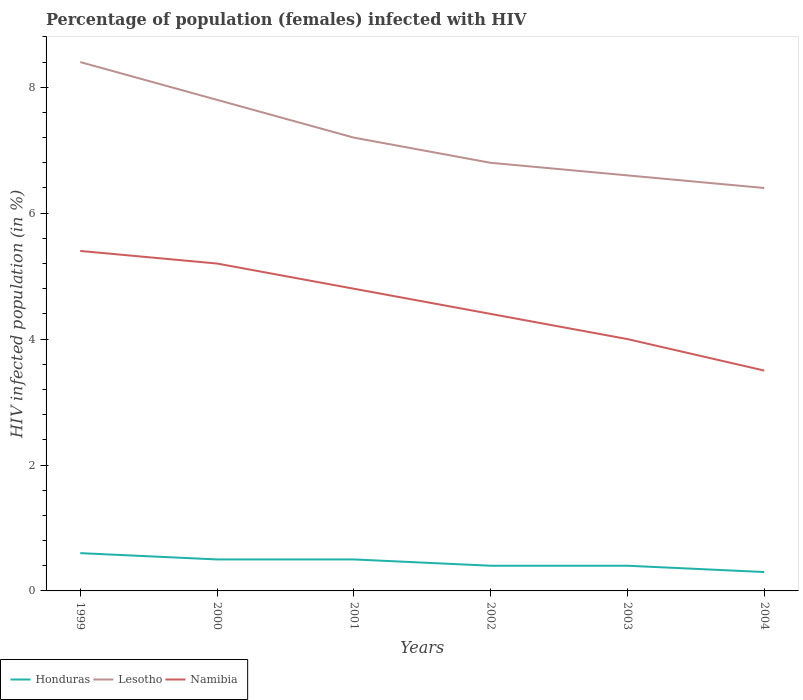How many different coloured lines are there?
Provide a short and direct response. 3. Across all years, what is the maximum percentage of HIV infected female population in Namibia?
Ensure brevity in your answer.  3.5. What is the total percentage of HIV infected female population in Honduras in the graph?
Offer a very short reply. 0.2. What is the difference between the highest and the lowest percentage of HIV infected female population in Lesotho?
Provide a succinct answer. 3. How many lines are there?
Your answer should be compact. 3. Are the values on the major ticks of Y-axis written in scientific E-notation?
Make the answer very short. No. Does the graph contain any zero values?
Provide a succinct answer. No. How are the legend labels stacked?
Your response must be concise. Horizontal. What is the title of the graph?
Your answer should be very brief. Percentage of population (females) infected with HIV. Does "Somalia" appear as one of the legend labels in the graph?
Offer a terse response. No. What is the label or title of the X-axis?
Your answer should be very brief. Years. What is the label or title of the Y-axis?
Offer a terse response. HIV infected population (in %). What is the HIV infected population (in %) in Namibia in 1999?
Your answer should be compact. 5.4. What is the HIV infected population (in %) of Honduras in 2000?
Ensure brevity in your answer.  0.5. What is the HIV infected population (in %) of Namibia in 2000?
Give a very brief answer. 5.2. What is the HIV infected population (in %) of Honduras in 2001?
Provide a succinct answer. 0.5. What is the HIV infected population (in %) of Namibia in 2001?
Your answer should be compact. 4.8. What is the HIV infected population (in %) in Lesotho in 2002?
Keep it short and to the point. 6.8. What is the HIV infected population (in %) in Namibia in 2002?
Ensure brevity in your answer.  4.4. What is the HIV infected population (in %) of Namibia in 2003?
Give a very brief answer. 4. What is the HIV infected population (in %) of Honduras in 2004?
Your answer should be very brief. 0.3. What is the HIV infected population (in %) of Lesotho in 2004?
Keep it short and to the point. 6.4. Across all years, what is the maximum HIV infected population (in %) in Honduras?
Offer a terse response. 0.6. Across all years, what is the maximum HIV infected population (in %) in Lesotho?
Offer a very short reply. 8.4. Across all years, what is the minimum HIV infected population (in %) in Honduras?
Your answer should be very brief. 0.3. Across all years, what is the minimum HIV infected population (in %) of Lesotho?
Your answer should be very brief. 6.4. Across all years, what is the minimum HIV infected population (in %) in Namibia?
Your answer should be very brief. 3.5. What is the total HIV infected population (in %) of Honduras in the graph?
Give a very brief answer. 2.7. What is the total HIV infected population (in %) of Lesotho in the graph?
Offer a terse response. 43.2. What is the total HIV infected population (in %) in Namibia in the graph?
Offer a very short reply. 27.3. What is the difference between the HIV infected population (in %) in Lesotho in 1999 and that in 2000?
Offer a very short reply. 0.6. What is the difference between the HIV infected population (in %) of Namibia in 1999 and that in 2000?
Your answer should be compact. 0.2. What is the difference between the HIV infected population (in %) of Lesotho in 1999 and that in 2001?
Offer a terse response. 1.2. What is the difference between the HIV infected population (in %) of Namibia in 1999 and that in 2002?
Ensure brevity in your answer.  1. What is the difference between the HIV infected population (in %) of Honduras in 1999 and that in 2003?
Provide a succinct answer. 0.2. What is the difference between the HIV infected population (in %) in Honduras in 1999 and that in 2004?
Give a very brief answer. 0.3. What is the difference between the HIV infected population (in %) of Namibia in 1999 and that in 2004?
Your answer should be very brief. 1.9. What is the difference between the HIV infected population (in %) of Lesotho in 2000 and that in 2001?
Make the answer very short. 0.6. What is the difference between the HIV infected population (in %) of Namibia in 2000 and that in 2001?
Provide a short and direct response. 0.4. What is the difference between the HIV infected population (in %) in Namibia in 2000 and that in 2002?
Offer a terse response. 0.8. What is the difference between the HIV infected population (in %) in Lesotho in 2000 and that in 2003?
Keep it short and to the point. 1.2. What is the difference between the HIV infected population (in %) in Namibia in 2000 and that in 2003?
Your answer should be very brief. 1.2. What is the difference between the HIV infected population (in %) of Honduras in 2000 and that in 2004?
Provide a short and direct response. 0.2. What is the difference between the HIV infected population (in %) in Namibia in 2000 and that in 2004?
Provide a short and direct response. 1.7. What is the difference between the HIV infected population (in %) in Honduras in 2001 and that in 2002?
Your response must be concise. 0.1. What is the difference between the HIV infected population (in %) in Namibia in 2001 and that in 2002?
Ensure brevity in your answer.  0.4. What is the difference between the HIV infected population (in %) in Honduras in 2001 and that in 2003?
Keep it short and to the point. 0.1. What is the difference between the HIV infected population (in %) in Namibia in 2001 and that in 2003?
Make the answer very short. 0.8. What is the difference between the HIV infected population (in %) of Namibia in 2001 and that in 2004?
Keep it short and to the point. 1.3. What is the difference between the HIV infected population (in %) of Honduras in 2002 and that in 2004?
Keep it short and to the point. 0.1. What is the difference between the HIV infected population (in %) of Honduras in 2003 and that in 2004?
Offer a very short reply. 0.1. What is the difference between the HIV infected population (in %) in Namibia in 2003 and that in 2004?
Keep it short and to the point. 0.5. What is the difference between the HIV infected population (in %) in Honduras in 1999 and the HIV infected population (in %) in Lesotho in 2000?
Keep it short and to the point. -7.2. What is the difference between the HIV infected population (in %) in Lesotho in 1999 and the HIV infected population (in %) in Namibia in 2000?
Offer a very short reply. 3.2. What is the difference between the HIV infected population (in %) of Honduras in 1999 and the HIV infected population (in %) of Namibia in 2001?
Your answer should be compact. -4.2. What is the difference between the HIV infected population (in %) in Honduras in 1999 and the HIV infected population (in %) in Lesotho in 2002?
Your answer should be compact. -6.2. What is the difference between the HIV infected population (in %) of Honduras in 1999 and the HIV infected population (in %) of Namibia in 2002?
Offer a terse response. -3.8. What is the difference between the HIV infected population (in %) in Lesotho in 1999 and the HIV infected population (in %) in Namibia in 2002?
Ensure brevity in your answer.  4. What is the difference between the HIV infected population (in %) in Honduras in 1999 and the HIV infected population (in %) in Lesotho in 2003?
Provide a short and direct response. -6. What is the difference between the HIV infected population (in %) of Honduras in 1999 and the HIV infected population (in %) of Namibia in 2003?
Offer a very short reply. -3.4. What is the difference between the HIV infected population (in %) of Lesotho in 1999 and the HIV infected population (in %) of Namibia in 2003?
Ensure brevity in your answer.  4.4. What is the difference between the HIV infected population (in %) of Lesotho in 1999 and the HIV infected population (in %) of Namibia in 2004?
Provide a succinct answer. 4.9. What is the difference between the HIV infected population (in %) of Honduras in 2000 and the HIV infected population (in %) of Lesotho in 2001?
Your answer should be very brief. -6.7. What is the difference between the HIV infected population (in %) in Lesotho in 2000 and the HIV infected population (in %) in Namibia in 2001?
Offer a very short reply. 3. What is the difference between the HIV infected population (in %) of Lesotho in 2000 and the HIV infected population (in %) of Namibia in 2002?
Offer a very short reply. 3.4. What is the difference between the HIV infected population (in %) of Honduras in 2000 and the HIV infected population (in %) of Namibia in 2003?
Provide a short and direct response. -3.5. What is the difference between the HIV infected population (in %) of Lesotho in 2000 and the HIV infected population (in %) of Namibia in 2004?
Make the answer very short. 4.3. What is the difference between the HIV infected population (in %) of Honduras in 2001 and the HIV infected population (in %) of Namibia in 2002?
Make the answer very short. -3.9. What is the difference between the HIV infected population (in %) of Honduras in 2001 and the HIV infected population (in %) of Namibia in 2003?
Keep it short and to the point. -3.5. What is the difference between the HIV infected population (in %) in Honduras in 2001 and the HIV infected population (in %) in Lesotho in 2004?
Provide a short and direct response. -5.9. What is the difference between the HIV infected population (in %) in Honduras in 2001 and the HIV infected population (in %) in Namibia in 2004?
Offer a very short reply. -3. What is the difference between the HIV infected population (in %) in Lesotho in 2001 and the HIV infected population (in %) in Namibia in 2004?
Offer a very short reply. 3.7. What is the difference between the HIV infected population (in %) of Honduras in 2002 and the HIV infected population (in %) of Lesotho in 2003?
Ensure brevity in your answer.  -6.2. What is the difference between the HIV infected population (in %) of Honduras in 2002 and the HIV infected population (in %) of Lesotho in 2004?
Ensure brevity in your answer.  -6. What is the difference between the HIV infected population (in %) of Honduras in 2002 and the HIV infected population (in %) of Namibia in 2004?
Offer a terse response. -3.1. What is the difference between the HIV infected population (in %) of Honduras in 2003 and the HIV infected population (in %) of Namibia in 2004?
Your response must be concise. -3.1. What is the difference between the HIV infected population (in %) in Lesotho in 2003 and the HIV infected population (in %) in Namibia in 2004?
Offer a terse response. 3.1. What is the average HIV infected population (in %) in Honduras per year?
Keep it short and to the point. 0.45. What is the average HIV infected population (in %) of Namibia per year?
Make the answer very short. 4.55. In the year 1999, what is the difference between the HIV infected population (in %) of Lesotho and HIV infected population (in %) of Namibia?
Your response must be concise. 3. In the year 2000, what is the difference between the HIV infected population (in %) in Honduras and HIV infected population (in %) in Lesotho?
Provide a short and direct response. -7.3. In the year 2001, what is the difference between the HIV infected population (in %) in Honduras and HIV infected population (in %) in Lesotho?
Your answer should be compact. -6.7. In the year 2003, what is the difference between the HIV infected population (in %) of Honduras and HIV infected population (in %) of Lesotho?
Make the answer very short. -6.2. In the year 2003, what is the difference between the HIV infected population (in %) of Honduras and HIV infected population (in %) of Namibia?
Make the answer very short. -3.6. In the year 2003, what is the difference between the HIV infected population (in %) of Lesotho and HIV infected population (in %) of Namibia?
Provide a succinct answer. 2.6. In the year 2004, what is the difference between the HIV infected population (in %) in Honduras and HIV infected population (in %) in Lesotho?
Your answer should be compact. -6.1. In the year 2004, what is the difference between the HIV infected population (in %) of Honduras and HIV infected population (in %) of Namibia?
Your answer should be compact. -3.2. What is the ratio of the HIV infected population (in %) in Honduras in 1999 to that in 2000?
Keep it short and to the point. 1.2. What is the ratio of the HIV infected population (in %) in Lesotho in 1999 to that in 2000?
Your answer should be very brief. 1.08. What is the ratio of the HIV infected population (in %) of Honduras in 1999 to that in 2001?
Ensure brevity in your answer.  1.2. What is the ratio of the HIV infected population (in %) of Namibia in 1999 to that in 2001?
Ensure brevity in your answer.  1.12. What is the ratio of the HIV infected population (in %) of Honduras in 1999 to that in 2002?
Provide a succinct answer. 1.5. What is the ratio of the HIV infected population (in %) of Lesotho in 1999 to that in 2002?
Ensure brevity in your answer.  1.24. What is the ratio of the HIV infected population (in %) of Namibia in 1999 to that in 2002?
Make the answer very short. 1.23. What is the ratio of the HIV infected population (in %) in Lesotho in 1999 to that in 2003?
Provide a succinct answer. 1.27. What is the ratio of the HIV infected population (in %) of Namibia in 1999 to that in 2003?
Ensure brevity in your answer.  1.35. What is the ratio of the HIV infected population (in %) in Honduras in 1999 to that in 2004?
Give a very brief answer. 2. What is the ratio of the HIV infected population (in %) of Lesotho in 1999 to that in 2004?
Your answer should be very brief. 1.31. What is the ratio of the HIV infected population (in %) of Namibia in 1999 to that in 2004?
Provide a short and direct response. 1.54. What is the ratio of the HIV infected population (in %) of Lesotho in 2000 to that in 2001?
Your response must be concise. 1.08. What is the ratio of the HIV infected population (in %) in Lesotho in 2000 to that in 2002?
Offer a very short reply. 1.15. What is the ratio of the HIV infected population (in %) in Namibia in 2000 to that in 2002?
Keep it short and to the point. 1.18. What is the ratio of the HIV infected population (in %) of Honduras in 2000 to that in 2003?
Keep it short and to the point. 1.25. What is the ratio of the HIV infected population (in %) in Lesotho in 2000 to that in 2003?
Provide a succinct answer. 1.18. What is the ratio of the HIV infected population (in %) of Lesotho in 2000 to that in 2004?
Provide a succinct answer. 1.22. What is the ratio of the HIV infected population (in %) of Namibia in 2000 to that in 2004?
Offer a very short reply. 1.49. What is the ratio of the HIV infected population (in %) in Lesotho in 2001 to that in 2002?
Offer a very short reply. 1.06. What is the ratio of the HIV infected population (in %) in Namibia in 2001 to that in 2002?
Your answer should be very brief. 1.09. What is the ratio of the HIV infected population (in %) in Lesotho in 2001 to that in 2003?
Make the answer very short. 1.09. What is the ratio of the HIV infected population (in %) in Honduras in 2001 to that in 2004?
Ensure brevity in your answer.  1.67. What is the ratio of the HIV infected population (in %) in Lesotho in 2001 to that in 2004?
Your answer should be compact. 1.12. What is the ratio of the HIV infected population (in %) of Namibia in 2001 to that in 2004?
Give a very brief answer. 1.37. What is the ratio of the HIV infected population (in %) in Lesotho in 2002 to that in 2003?
Keep it short and to the point. 1.03. What is the ratio of the HIV infected population (in %) of Namibia in 2002 to that in 2003?
Your answer should be compact. 1.1. What is the ratio of the HIV infected population (in %) in Lesotho in 2002 to that in 2004?
Provide a succinct answer. 1.06. What is the ratio of the HIV infected population (in %) of Namibia in 2002 to that in 2004?
Offer a very short reply. 1.26. What is the ratio of the HIV infected population (in %) of Honduras in 2003 to that in 2004?
Offer a terse response. 1.33. What is the ratio of the HIV infected population (in %) in Lesotho in 2003 to that in 2004?
Provide a succinct answer. 1.03. What is the difference between the highest and the lowest HIV infected population (in %) of Namibia?
Your answer should be very brief. 1.9. 